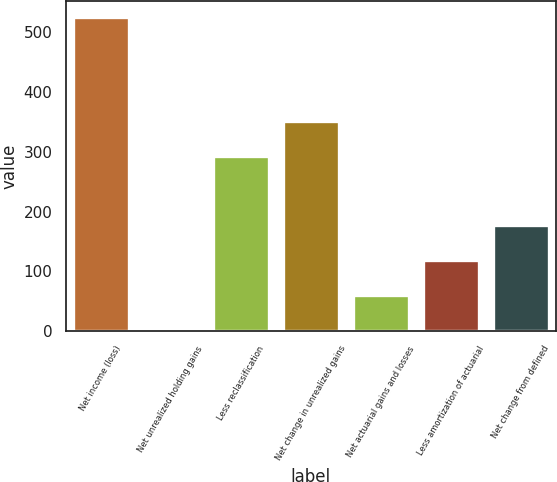Convert chart. <chart><loc_0><loc_0><loc_500><loc_500><bar_chart><fcel>Net income (loss)<fcel>Net unrealized holding gains<fcel>Less reclassification<fcel>Net change in unrealized gains<fcel>Net actuarial gains and losses<fcel>Less amortization of actuarial<fcel>Net change from defined<nl><fcel>525.9<fcel>3<fcel>293.5<fcel>351.6<fcel>61.1<fcel>119.2<fcel>177.3<nl></chart> 